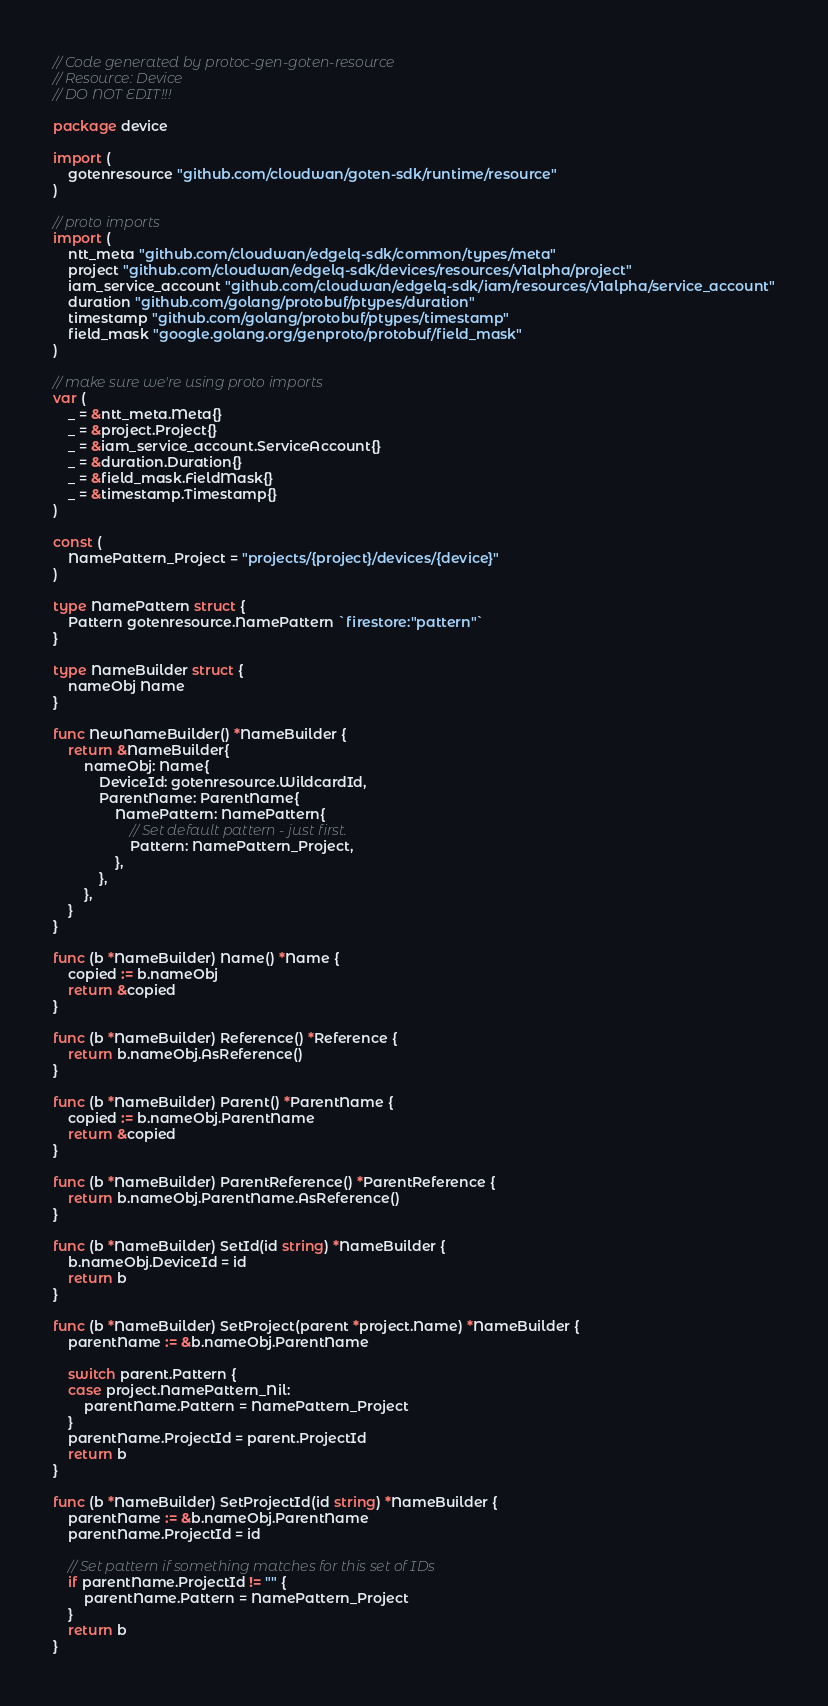<code> <loc_0><loc_0><loc_500><loc_500><_Go_>// Code generated by protoc-gen-goten-resource
// Resource: Device
// DO NOT EDIT!!!

package device

import (
	gotenresource "github.com/cloudwan/goten-sdk/runtime/resource"
)

// proto imports
import (
	ntt_meta "github.com/cloudwan/edgelq-sdk/common/types/meta"
	project "github.com/cloudwan/edgelq-sdk/devices/resources/v1alpha/project"
	iam_service_account "github.com/cloudwan/edgelq-sdk/iam/resources/v1alpha/service_account"
	duration "github.com/golang/protobuf/ptypes/duration"
	timestamp "github.com/golang/protobuf/ptypes/timestamp"
	field_mask "google.golang.org/genproto/protobuf/field_mask"
)

// make sure we're using proto imports
var (
	_ = &ntt_meta.Meta{}
	_ = &project.Project{}
	_ = &iam_service_account.ServiceAccount{}
	_ = &duration.Duration{}
	_ = &field_mask.FieldMask{}
	_ = &timestamp.Timestamp{}
)

const (
	NamePattern_Project = "projects/{project}/devices/{device}"
)

type NamePattern struct {
	Pattern gotenresource.NamePattern `firestore:"pattern"`
}

type NameBuilder struct {
	nameObj Name
}

func NewNameBuilder() *NameBuilder {
	return &NameBuilder{
		nameObj: Name{
			DeviceId: gotenresource.WildcardId,
			ParentName: ParentName{
				NamePattern: NamePattern{
					// Set default pattern - just first.
					Pattern: NamePattern_Project,
				},
			},
		},
	}
}

func (b *NameBuilder) Name() *Name {
	copied := b.nameObj
	return &copied
}

func (b *NameBuilder) Reference() *Reference {
	return b.nameObj.AsReference()
}

func (b *NameBuilder) Parent() *ParentName {
	copied := b.nameObj.ParentName
	return &copied
}

func (b *NameBuilder) ParentReference() *ParentReference {
	return b.nameObj.ParentName.AsReference()
}

func (b *NameBuilder) SetId(id string) *NameBuilder {
	b.nameObj.DeviceId = id
	return b
}

func (b *NameBuilder) SetProject(parent *project.Name) *NameBuilder {
	parentName := &b.nameObj.ParentName

	switch parent.Pattern {
	case project.NamePattern_Nil:
		parentName.Pattern = NamePattern_Project
	}
	parentName.ProjectId = parent.ProjectId
	return b
}

func (b *NameBuilder) SetProjectId(id string) *NameBuilder {
	parentName := &b.nameObj.ParentName
	parentName.ProjectId = id

	// Set pattern if something matches for this set of IDs
	if parentName.ProjectId != "" {
		parentName.Pattern = NamePattern_Project
	}
	return b
}
</code> 